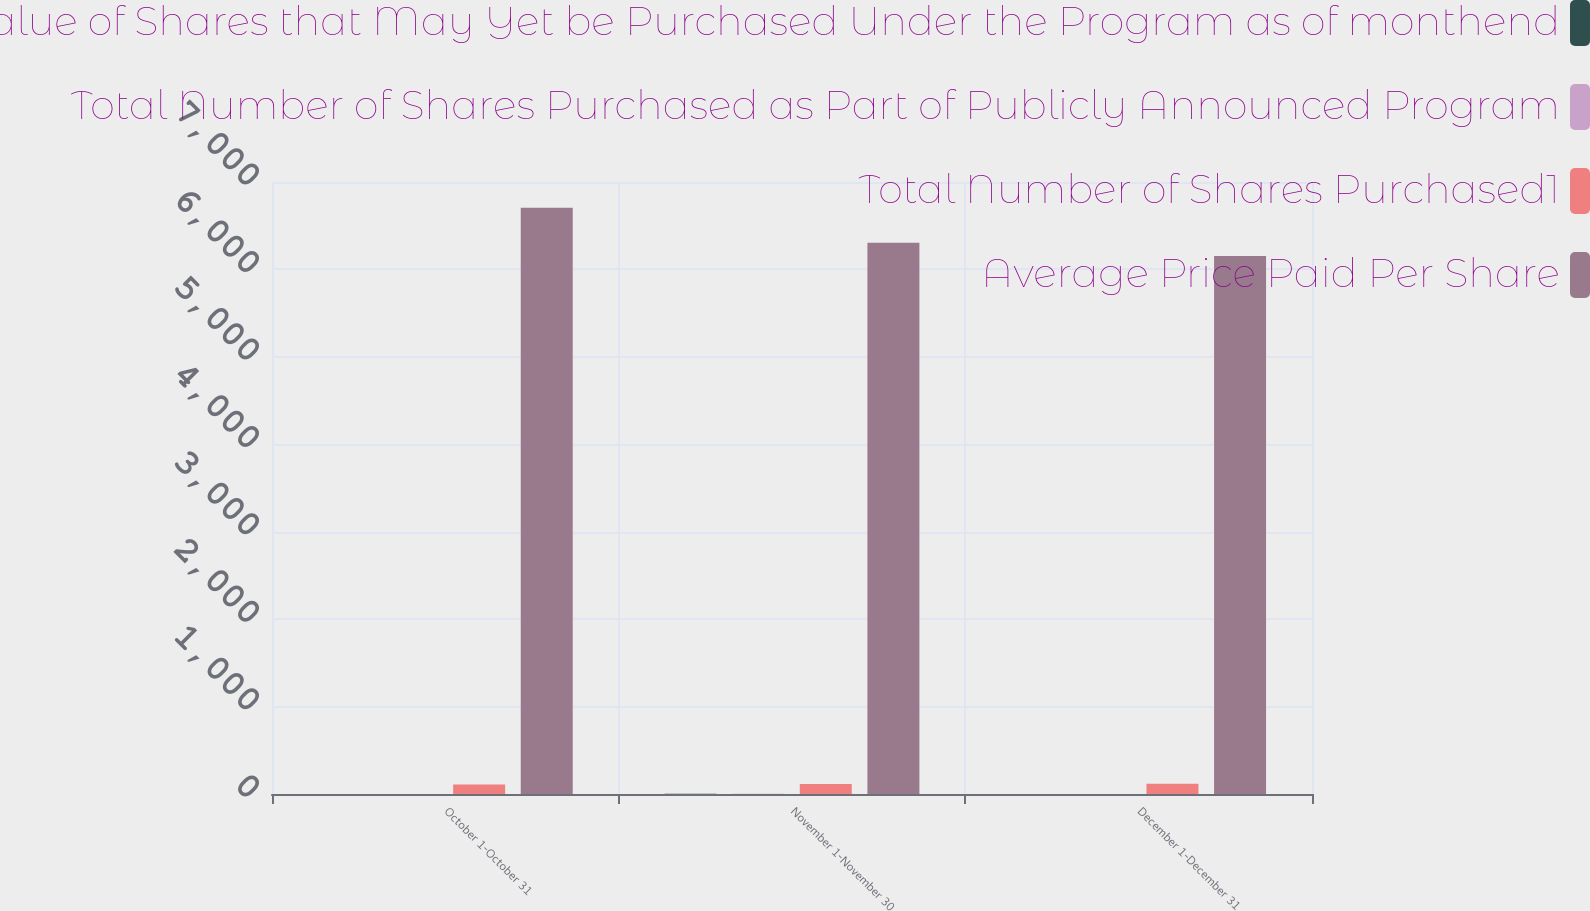Convert chart. <chart><loc_0><loc_0><loc_500><loc_500><stacked_bar_chart><ecel><fcel>October 1-October 31<fcel>November 1-November 30<fcel>December 1-December 31<nl><fcel>Approximate Dollar Value of Shares that May Yet be Purchased Under the Program as of monthend<fcel>1.2<fcel>3.5<fcel>1.3<nl><fcel>Total Number of Shares Purchased as Part of Publicly Announced Program<fcel>1.2<fcel>3.5<fcel>1.3<nl><fcel>Total Number of Shares Purchased1<fcel>108.52<fcel>114.35<fcel>117.14<nl><fcel>Average Price Paid Per Share<fcel>6706<fcel>6306<fcel>6154<nl></chart> 